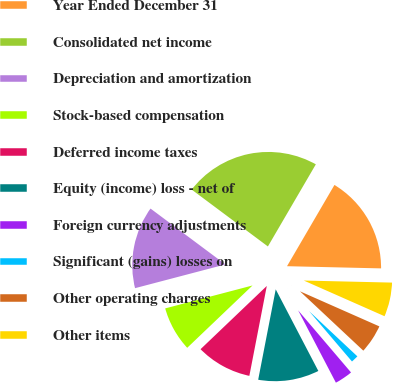<chart> <loc_0><loc_0><loc_500><loc_500><pie_chart><fcel>Year Ended December 31<fcel>Consolidated net income<fcel>Depreciation and amortization<fcel>Stock-based compensation<fcel>Deferred income taxes<fcel>Equity (income) loss - net of<fcel>Foreign currency adjustments<fcel>Significant (gains) losses on<fcel>Other operating charges<fcel>Other items<nl><fcel>16.96%<fcel>23.21%<fcel>14.29%<fcel>8.04%<fcel>9.82%<fcel>10.71%<fcel>3.57%<fcel>1.79%<fcel>5.36%<fcel>6.25%<nl></chart> 